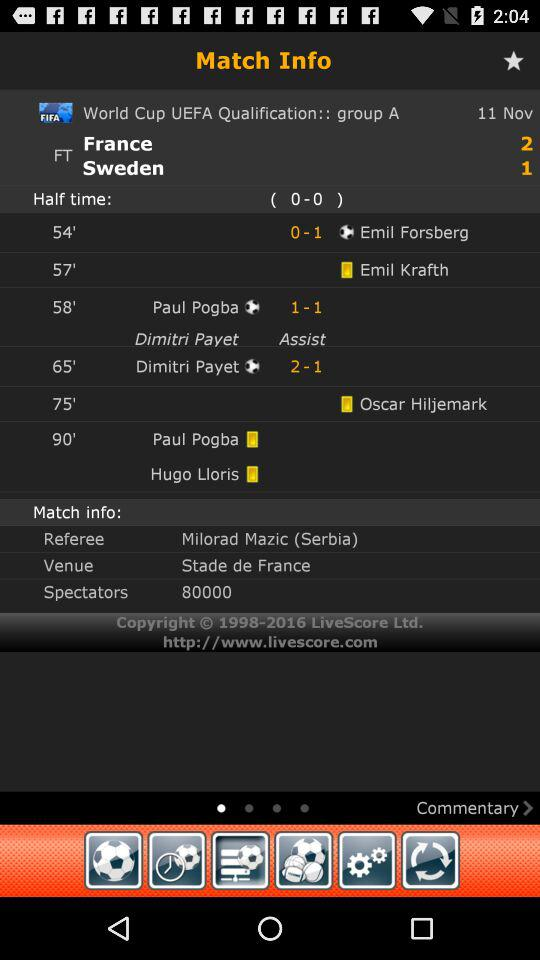What is the score on half time? The score is 0-0. 